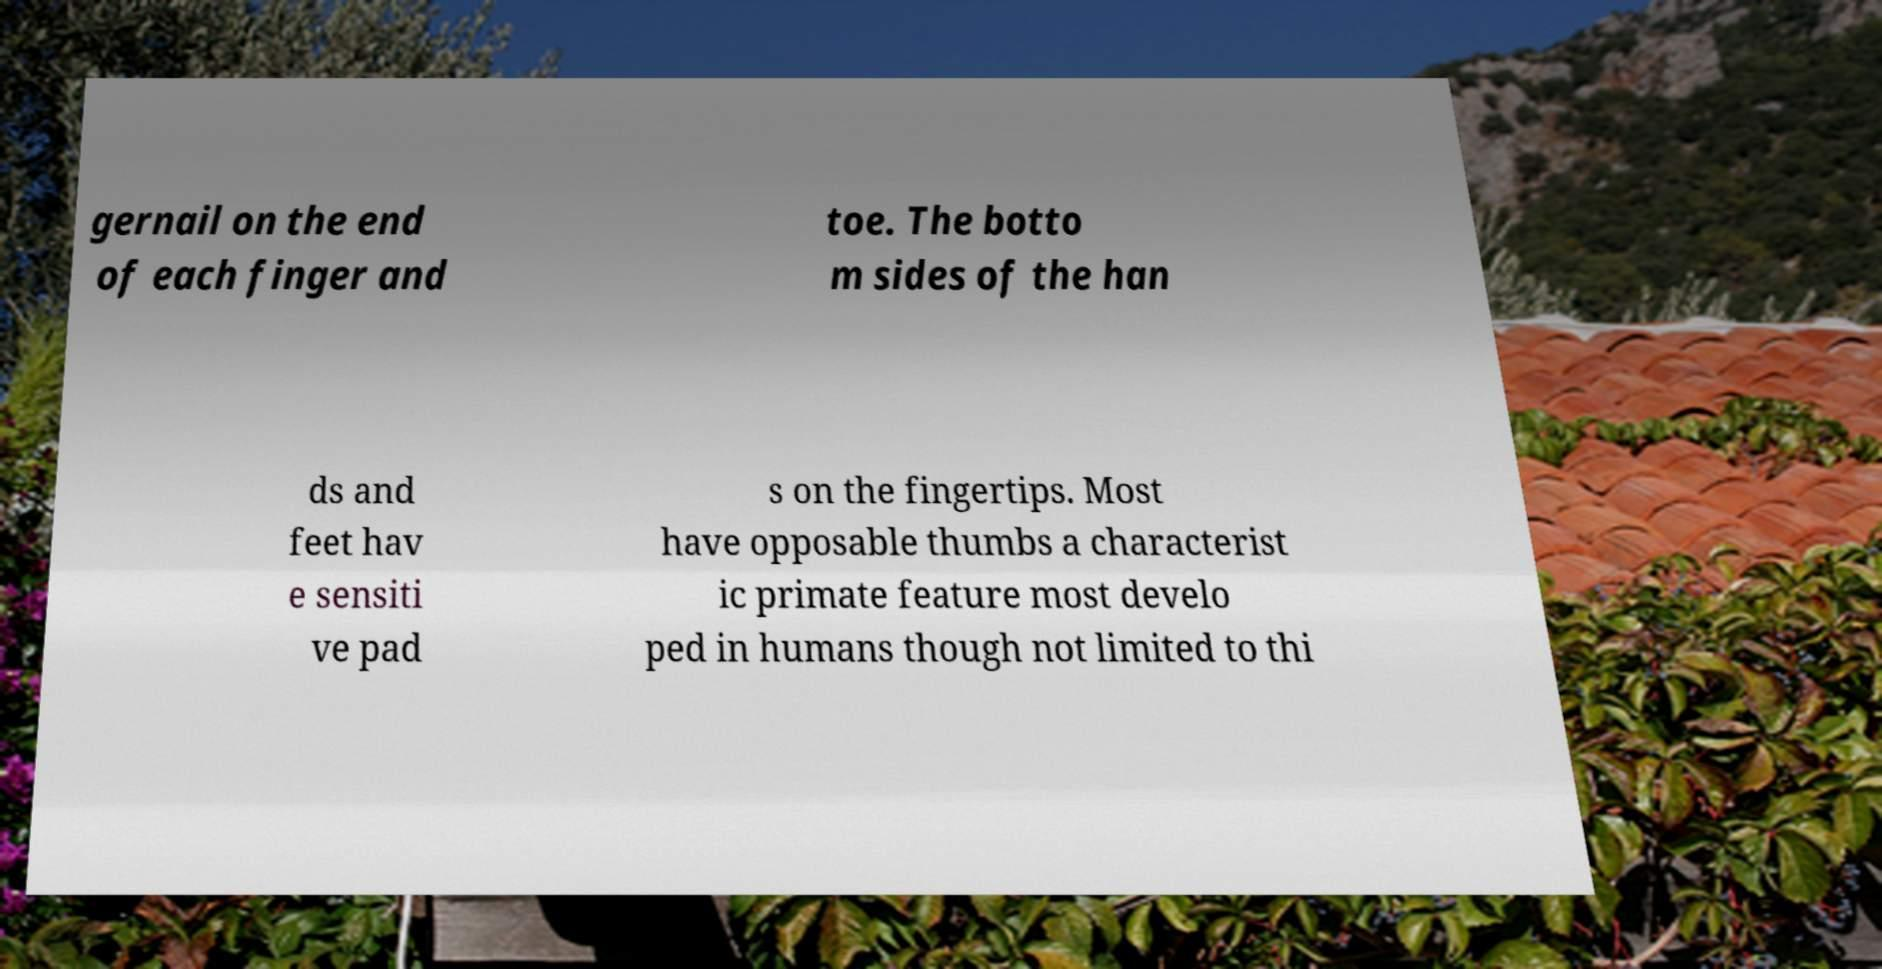Please read and relay the text visible in this image. What does it say? gernail on the end of each finger and toe. The botto m sides of the han ds and feet hav e sensiti ve pad s on the fingertips. Most have opposable thumbs a characterist ic primate feature most develo ped in humans though not limited to thi 